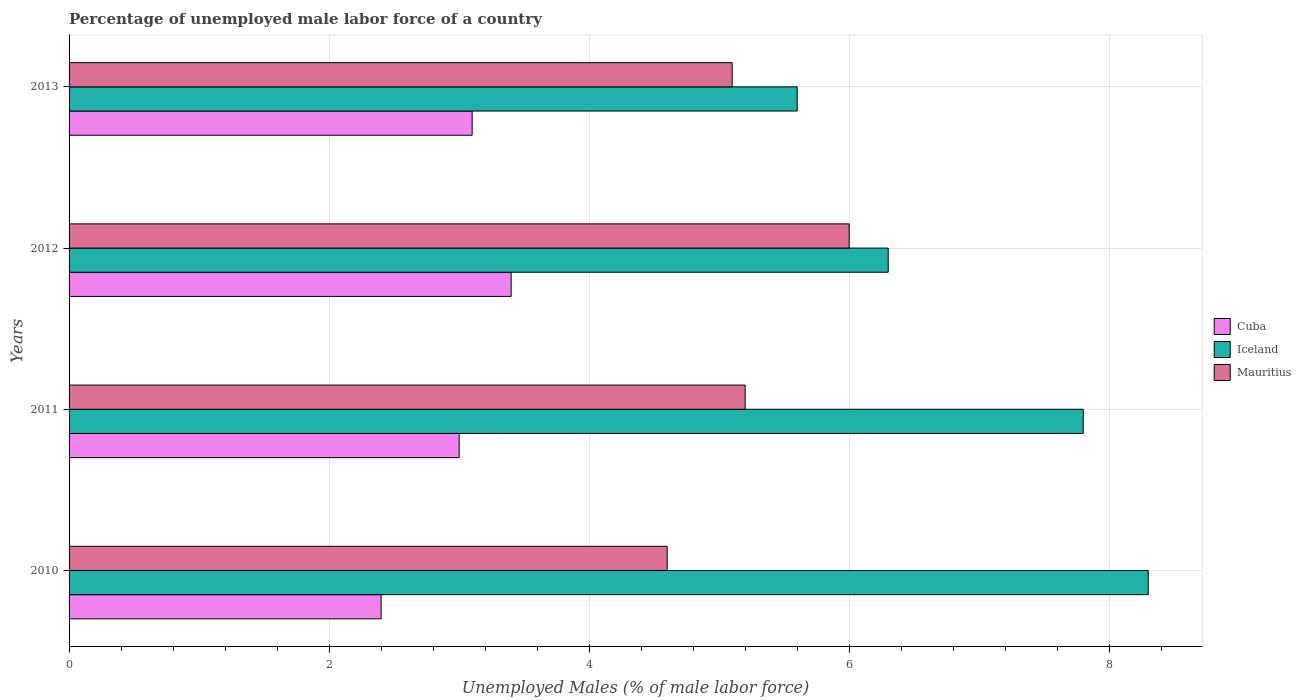Are the number of bars per tick equal to the number of legend labels?
Provide a succinct answer. Yes. How many bars are there on the 4th tick from the top?
Your answer should be very brief. 3. What is the label of the 4th group of bars from the top?
Keep it short and to the point. 2010. What is the percentage of unemployed male labor force in Iceland in 2012?
Make the answer very short. 6.3. Across all years, what is the maximum percentage of unemployed male labor force in Mauritius?
Provide a short and direct response. 6. Across all years, what is the minimum percentage of unemployed male labor force in Cuba?
Give a very brief answer. 2.4. In which year was the percentage of unemployed male labor force in Mauritius maximum?
Provide a short and direct response. 2012. What is the total percentage of unemployed male labor force in Mauritius in the graph?
Provide a short and direct response. 20.9. What is the difference between the percentage of unemployed male labor force in Mauritius in 2010 and that in 2013?
Your response must be concise. -0.5. What is the difference between the percentage of unemployed male labor force in Cuba in 2010 and the percentage of unemployed male labor force in Iceland in 2012?
Your answer should be very brief. -3.9. What is the average percentage of unemployed male labor force in Mauritius per year?
Your response must be concise. 5.22. In how many years, is the percentage of unemployed male labor force in Mauritius greater than 8 %?
Your answer should be compact. 0. What is the ratio of the percentage of unemployed male labor force in Cuba in 2011 to that in 2012?
Provide a short and direct response. 0.88. What is the difference between the highest and the second highest percentage of unemployed male labor force in Cuba?
Offer a very short reply. 0.3. What is the difference between the highest and the lowest percentage of unemployed male labor force in Mauritius?
Your answer should be compact. 1.4. In how many years, is the percentage of unemployed male labor force in Iceland greater than the average percentage of unemployed male labor force in Iceland taken over all years?
Provide a succinct answer. 2. Is the sum of the percentage of unemployed male labor force in Iceland in 2012 and 2013 greater than the maximum percentage of unemployed male labor force in Mauritius across all years?
Provide a short and direct response. Yes. What does the 1st bar from the top in 2010 represents?
Your answer should be very brief. Mauritius. How many years are there in the graph?
Your answer should be very brief. 4. Does the graph contain grids?
Ensure brevity in your answer.  Yes. Where does the legend appear in the graph?
Give a very brief answer. Center right. How are the legend labels stacked?
Make the answer very short. Vertical. What is the title of the graph?
Your response must be concise. Percentage of unemployed male labor force of a country. What is the label or title of the X-axis?
Offer a very short reply. Unemployed Males (% of male labor force). What is the Unemployed Males (% of male labor force) in Cuba in 2010?
Give a very brief answer. 2.4. What is the Unemployed Males (% of male labor force) in Iceland in 2010?
Ensure brevity in your answer.  8.3. What is the Unemployed Males (% of male labor force) of Mauritius in 2010?
Your answer should be very brief. 4.6. What is the Unemployed Males (% of male labor force) in Cuba in 2011?
Your response must be concise. 3. What is the Unemployed Males (% of male labor force) in Iceland in 2011?
Ensure brevity in your answer.  7.8. What is the Unemployed Males (% of male labor force) of Mauritius in 2011?
Ensure brevity in your answer.  5.2. What is the Unemployed Males (% of male labor force) in Cuba in 2012?
Your answer should be compact. 3.4. What is the Unemployed Males (% of male labor force) of Iceland in 2012?
Provide a succinct answer. 6.3. What is the Unemployed Males (% of male labor force) of Cuba in 2013?
Your response must be concise. 3.1. What is the Unemployed Males (% of male labor force) of Iceland in 2013?
Your answer should be compact. 5.6. What is the Unemployed Males (% of male labor force) of Mauritius in 2013?
Your response must be concise. 5.1. Across all years, what is the maximum Unemployed Males (% of male labor force) of Cuba?
Your response must be concise. 3.4. Across all years, what is the maximum Unemployed Males (% of male labor force) of Iceland?
Your answer should be compact. 8.3. Across all years, what is the minimum Unemployed Males (% of male labor force) in Cuba?
Offer a very short reply. 2.4. Across all years, what is the minimum Unemployed Males (% of male labor force) of Iceland?
Your response must be concise. 5.6. Across all years, what is the minimum Unemployed Males (% of male labor force) in Mauritius?
Your answer should be very brief. 4.6. What is the total Unemployed Males (% of male labor force) of Mauritius in the graph?
Your answer should be very brief. 20.9. What is the difference between the Unemployed Males (% of male labor force) of Mauritius in 2010 and that in 2011?
Offer a very short reply. -0.6. What is the difference between the Unemployed Males (% of male labor force) of Cuba in 2010 and that in 2012?
Offer a terse response. -1. What is the difference between the Unemployed Males (% of male labor force) of Iceland in 2010 and that in 2012?
Offer a very short reply. 2. What is the difference between the Unemployed Males (% of male labor force) in Cuba in 2010 and that in 2013?
Keep it short and to the point. -0.7. What is the difference between the Unemployed Males (% of male labor force) of Iceland in 2010 and that in 2013?
Offer a very short reply. 2.7. What is the difference between the Unemployed Males (% of male labor force) in Cuba in 2011 and that in 2012?
Your answer should be very brief. -0.4. What is the difference between the Unemployed Males (% of male labor force) of Iceland in 2011 and that in 2013?
Offer a very short reply. 2.2. What is the difference between the Unemployed Males (% of male labor force) of Mauritius in 2011 and that in 2013?
Provide a succinct answer. 0.1. What is the difference between the Unemployed Males (% of male labor force) of Iceland in 2012 and that in 2013?
Provide a succinct answer. 0.7. What is the difference between the Unemployed Males (% of male labor force) in Cuba in 2010 and the Unemployed Males (% of male labor force) in Mauritius in 2011?
Offer a very short reply. -2.8. What is the difference between the Unemployed Males (% of male labor force) of Iceland in 2010 and the Unemployed Males (% of male labor force) of Mauritius in 2012?
Your answer should be very brief. 2.3. What is the difference between the Unemployed Males (% of male labor force) of Cuba in 2010 and the Unemployed Males (% of male labor force) of Iceland in 2013?
Provide a short and direct response. -3.2. What is the difference between the Unemployed Males (% of male labor force) in Cuba in 2010 and the Unemployed Males (% of male labor force) in Mauritius in 2013?
Make the answer very short. -2.7. What is the difference between the Unemployed Males (% of male labor force) in Cuba in 2011 and the Unemployed Males (% of male labor force) in Iceland in 2012?
Make the answer very short. -3.3. What is the difference between the Unemployed Males (% of male labor force) of Cuba in 2011 and the Unemployed Males (% of male labor force) of Iceland in 2013?
Your response must be concise. -2.6. What is the difference between the Unemployed Males (% of male labor force) in Iceland in 2011 and the Unemployed Males (% of male labor force) in Mauritius in 2013?
Your answer should be compact. 2.7. What is the average Unemployed Males (% of male labor force) in Cuba per year?
Provide a succinct answer. 2.98. What is the average Unemployed Males (% of male labor force) of Mauritius per year?
Make the answer very short. 5.22. In the year 2010, what is the difference between the Unemployed Males (% of male labor force) of Cuba and Unemployed Males (% of male labor force) of Iceland?
Offer a terse response. -5.9. In the year 2011, what is the difference between the Unemployed Males (% of male labor force) of Cuba and Unemployed Males (% of male labor force) of Iceland?
Ensure brevity in your answer.  -4.8. In the year 2011, what is the difference between the Unemployed Males (% of male labor force) in Cuba and Unemployed Males (% of male labor force) in Mauritius?
Ensure brevity in your answer.  -2.2. In the year 2011, what is the difference between the Unemployed Males (% of male labor force) of Iceland and Unemployed Males (% of male labor force) of Mauritius?
Keep it short and to the point. 2.6. In the year 2013, what is the difference between the Unemployed Males (% of male labor force) in Cuba and Unemployed Males (% of male labor force) in Mauritius?
Offer a very short reply. -2. What is the ratio of the Unemployed Males (% of male labor force) of Iceland in 2010 to that in 2011?
Your answer should be very brief. 1.06. What is the ratio of the Unemployed Males (% of male labor force) of Mauritius in 2010 to that in 2011?
Your response must be concise. 0.88. What is the ratio of the Unemployed Males (% of male labor force) of Cuba in 2010 to that in 2012?
Make the answer very short. 0.71. What is the ratio of the Unemployed Males (% of male labor force) in Iceland in 2010 to that in 2012?
Provide a succinct answer. 1.32. What is the ratio of the Unemployed Males (% of male labor force) in Mauritius in 2010 to that in 2012?
Your answer should be compact. 0.77. What is the ratio of the Unemployed Males (% of male labor force) of Cuba in 2010 to that in 2013?
Offer a very short reply. 0.77. What is the ratio of the Unemployed Males (% of male labor force) of Iceland in 2010 to that in 2013?
Keep it short and to the point. 1.48. What is the ratio of the Unemployed Males (% of male labor force) of Mauritius in 2010 to that in 2013?
Offer a very short reply. 0.9. What is the ratio of the Unemployed Males (% of male labor force) of Cuba in 2011 to that in 2012?
Make the answer very short. 0.88. What is the ratio of the Unemployed Males (% of male labor force) in Iceland in 2011 to that in 2012?
Offer a terse response. 1.24. What is the ratio of the Unemployed Males (% of male labor force) in Mauritius in 2011 to that in 2012?
Provide a succinct answer. 0.87. What is the ratio of the Unemployed Males (% of male labor force) of Iceland in 2011 to that in 2013?
Your answer should be compact. 1.39. What is the ratio of the Unemployed Males (% of male labor force) of Mauritius in 2011 to that in 2013?
Provide a succinct answer. 1.02. What is the ratio of the Unemployed Males (% of male labor force) of Cuba in 2012 to that in 2013?
Offer a very short reply. 1.1. What is the ratio of the Unemployed Males (% of male labor force) in Iceland in 2012 to that in 2013?
Make the answer very short. 1.12. What is the ratio of the Unemployed Males (% of male labor force) in Mauritius in 2012 to that in 2013?
Offer a terse response. 1.18. What is the difference between the highest and the second highest Unemployed Males (% of male labor force) in Cuba?
Provide a short and direct response. 0.3. What is the difference between the highest and the second highest Unemployed Males (% of male labor force) in Iceland?
Offer a very short reply. 0.5. What is the difference between the highest and the second highest Unemployed Males (% of male labor force) in Mauritius?
Your answer should be compact. 0.8. What is the difference between the highest and the lowest Unemployed Males (% of male labor force) in Iceland?
Your answer should be compact. 2.7. 